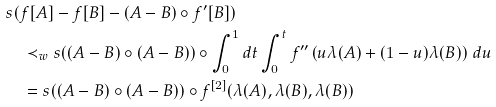<formula> <loc_0><loc_0><loc_500><loc_500>& s ( f [ A ] - f [ B ] - ( A - B ) \circ f ^ { \prime } [ B ] ) \\ & \quad \prec _ { w } s ( ( A - B ) \circ ( A - B ) ) \circ \int _ { 0 } ^ { 1 } d t \int _ { 0 } ^ { t } f ^ { \prime \prime } \left ( u \lambda ( A ) + ( 1 - u ) \lambda ( B ) \right ) \, d u \\ & \quad = s ( ( A - B ) \circ ( A - B ) ) \circ f ^ { [ 2 ] } ( \lambda ( A ) , \lambda ( B ) , \lambda ( B ) )</formula> 